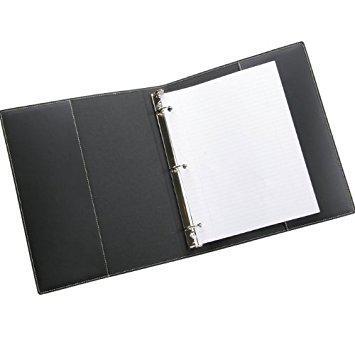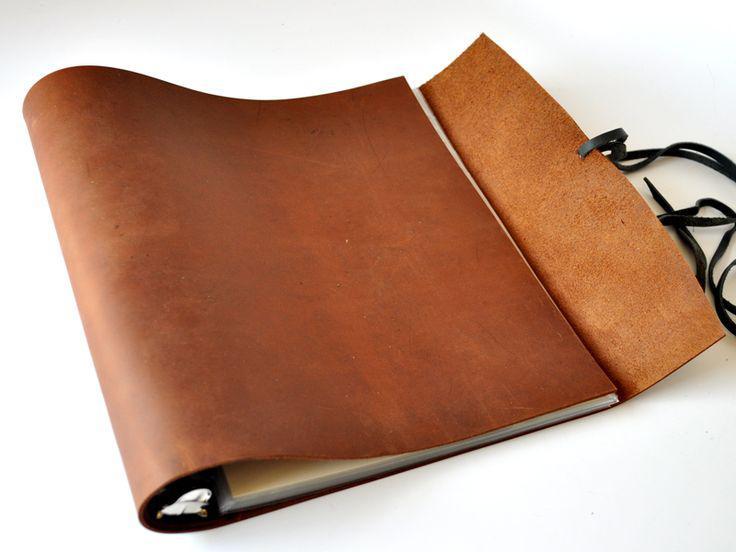The first image is the image on the left, the second image is the image on the right. Considering the images on both sides, is "Both binders are against a white background." valid? Answer yes or no. Yes. The first image is the image on the left, the second image is the image on the right. Analyze the images presented: Is the assertion "Each image contains a single brown binder" valid? Answer yes or no. No. 